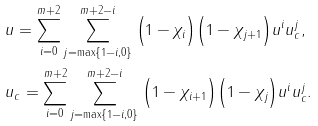<formula> <loc_0><loc_0><loc_500><loc_500>& u = \sum _ { i = 0 } ^ { m + 2 } \sum _ { j = \max \{ 1 - i , 0 \} } ^ { m + 2 - i } \Big { ( } 1 - \chi _ { i } \Big { ) } \Big { ( } 1 - \chi _ { j + 1 } \Big { ) } u ^ { i } u _ { c } ^ { j } , \\ & u _ { c } = \sum _ { i = 0 } ^ { m + 2 } \sum _ { j = \max \{ 1 - i , 0 \} } ^ { m + 2 - i } \Big { ( } 1 - \chi _ { i + 1 } \Big { ) } \Big { ( } 1 - \chi _ { j } \Big { ) } u ^ { i } u _ { c } ^ { j } .</formula> 